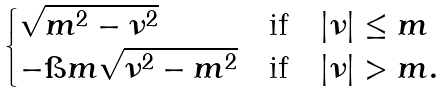Convert formula to latex. <formula><loc_0><loc_0><loc_500><loc_500>\begin{cases} \sqrt { m ^ { 2 } - \nu ^ { 2 } } & \text {if} \quad | \nu | \leq m \\ - \i m \sqrt { \nu ^ { 2 } - m ^ { 2 } } & \text {if} \quad | \nu | > m . \end{cases}</formula> 